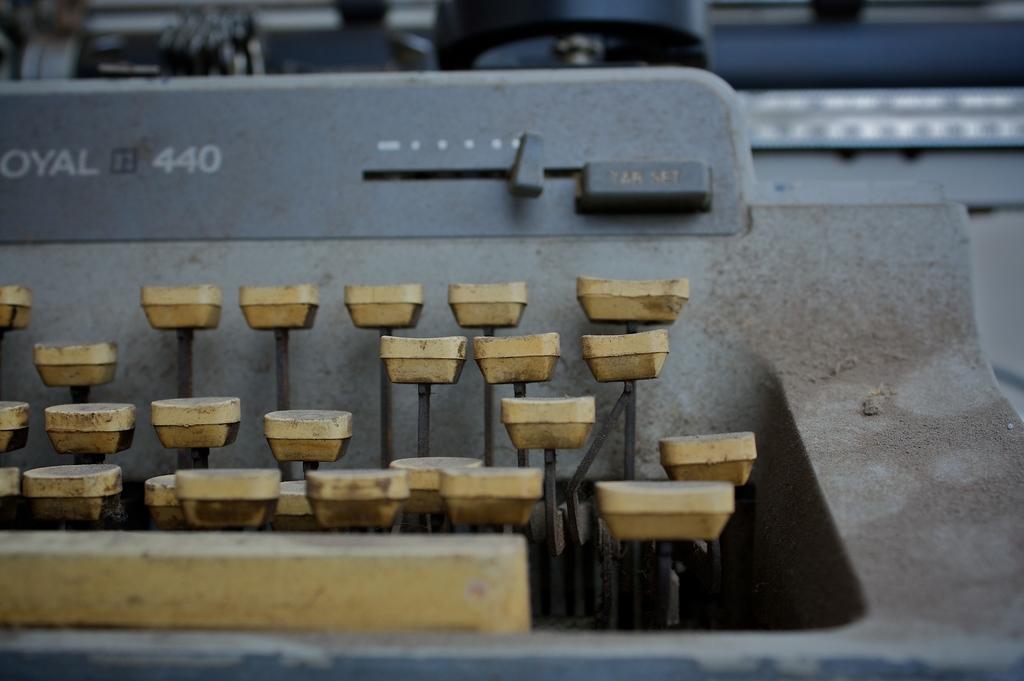What number is on the typewriter?
Provide a succinct answer. 440. 